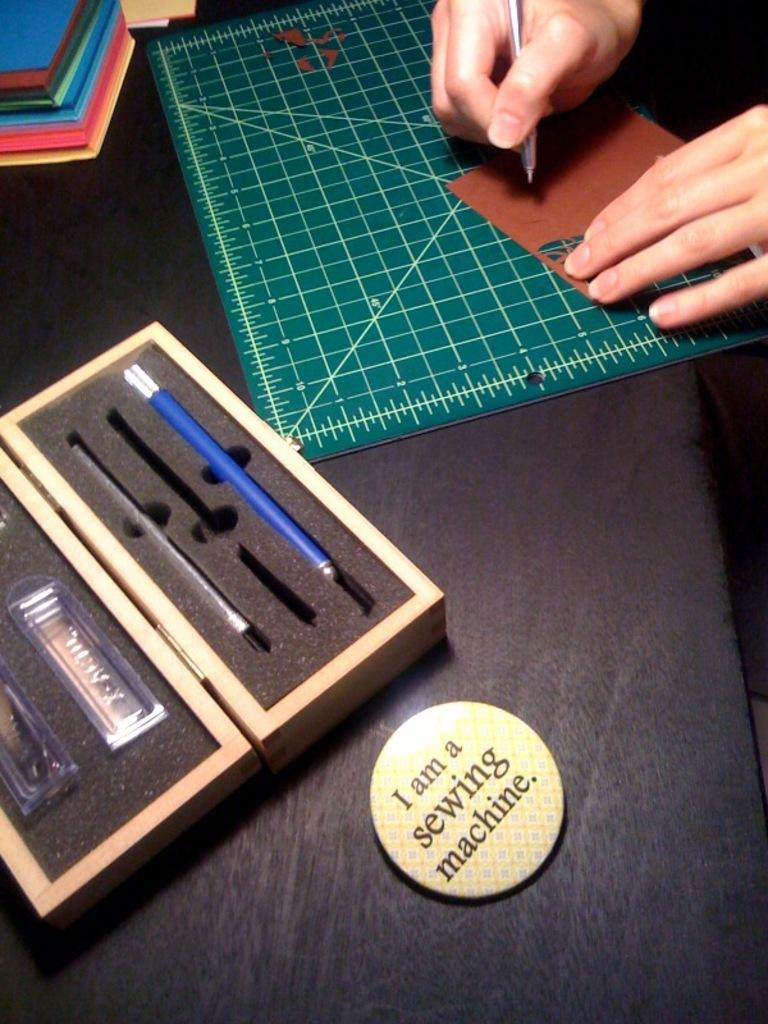What object can be seen in the image that is often used for identification? There is a badge in the image. What item is visible in the image that is typically used for storing pens? There is a pen box in the image. What can be seen on the table in the image? There are books on the table in the image. What piece of furniture is visible in the image? The table is visible in the image. What action is being performed by a person's hand in the top right side of the image? A person's hand is holding a pen in the top right side of the image. What type of plane is visible in the image? There is no plane visible in the image. 